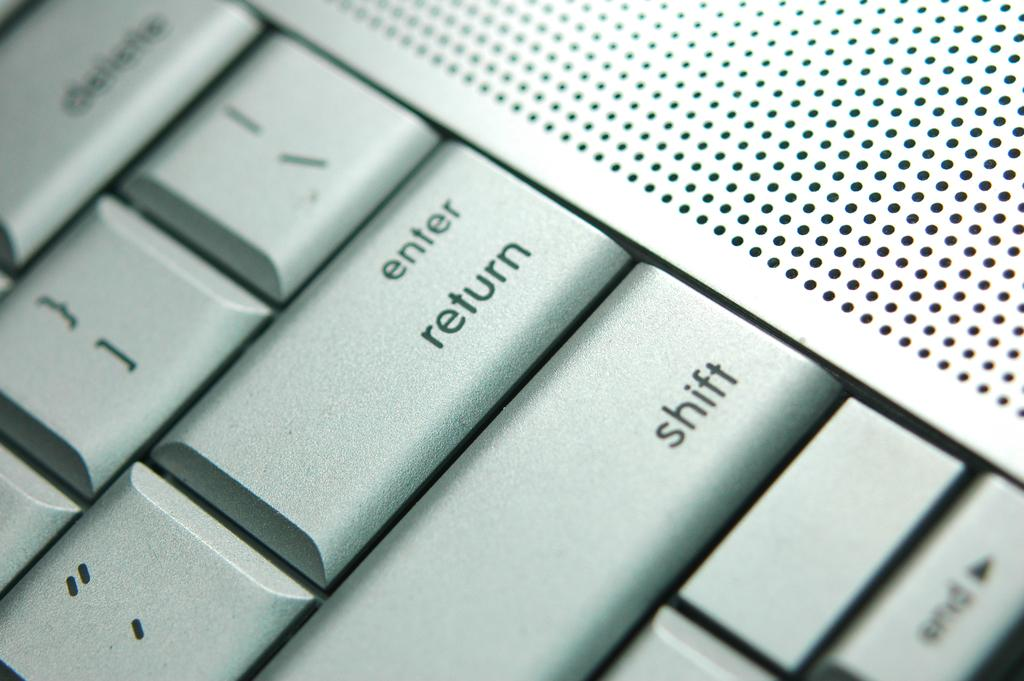<image>
Render a clear and concise summary of the photo. a keyboard that has the word return on it 